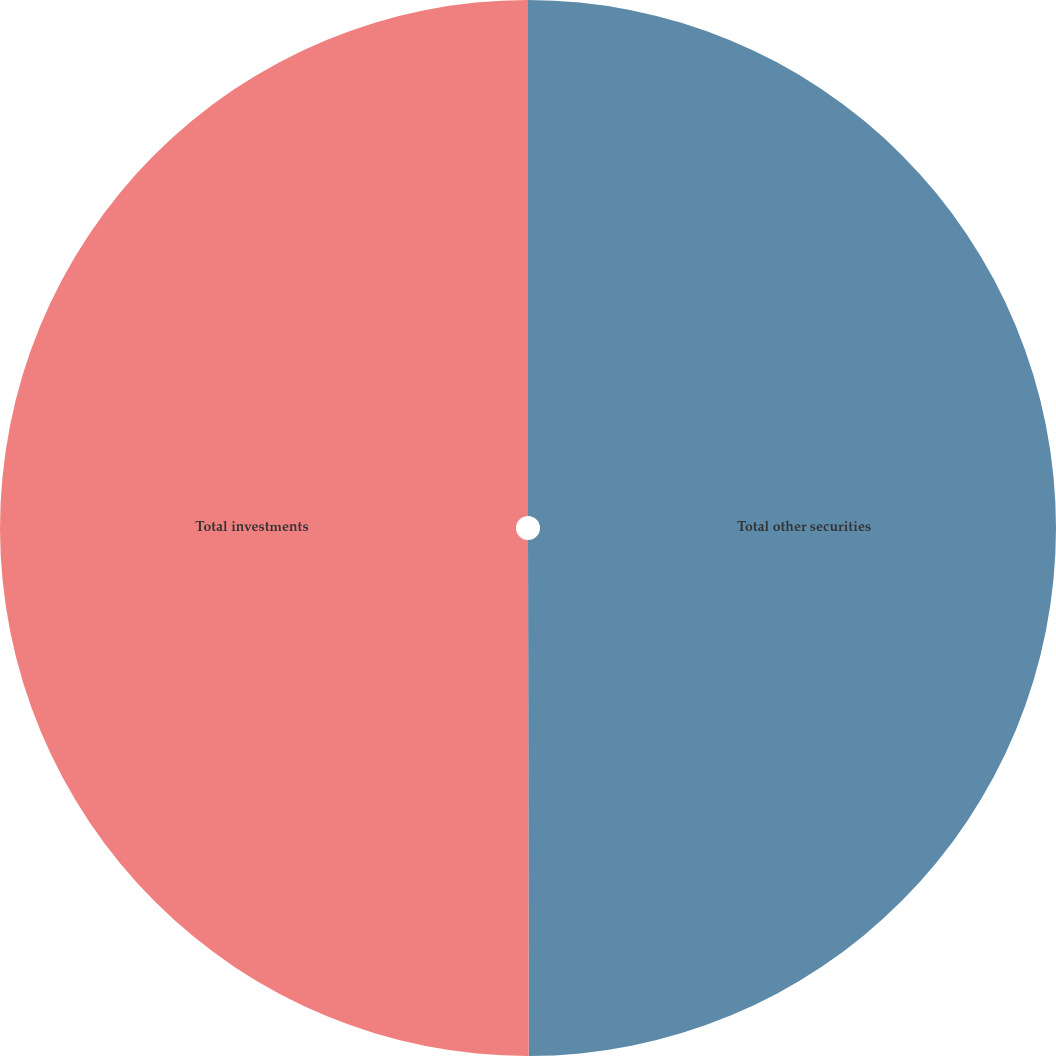Convert chart. <chart><loc_0><loc_0><loc_500><loc_500><pie_chart><fcel>Total other securities<fcel>Total investments<nl><fcel>49.98%<fcel>50.02%<nl></chart> 